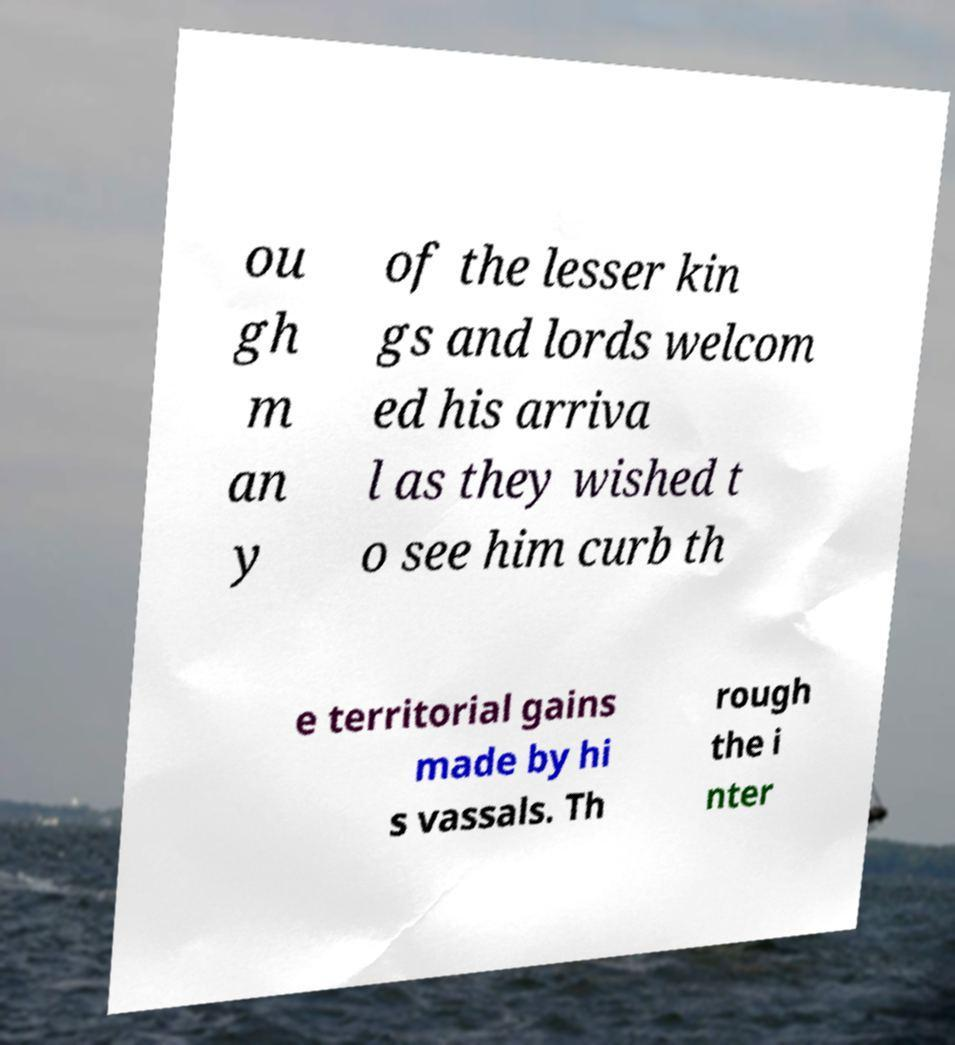What messages or text are displayed in this image? I need them in a readable, typed format. ou gh m an y of the lesser kin gs and lords welcom ed his arriva l as they wished t o see him curb th e territorial gains made by hi s vassals. Th rough the i nter 